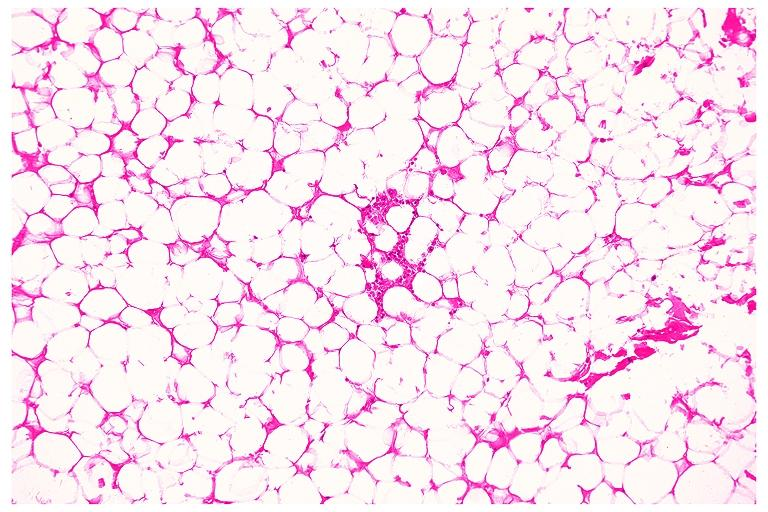s absence of palpebral fissure cleft palate present?
Answer the question using a single word or phrase. No 